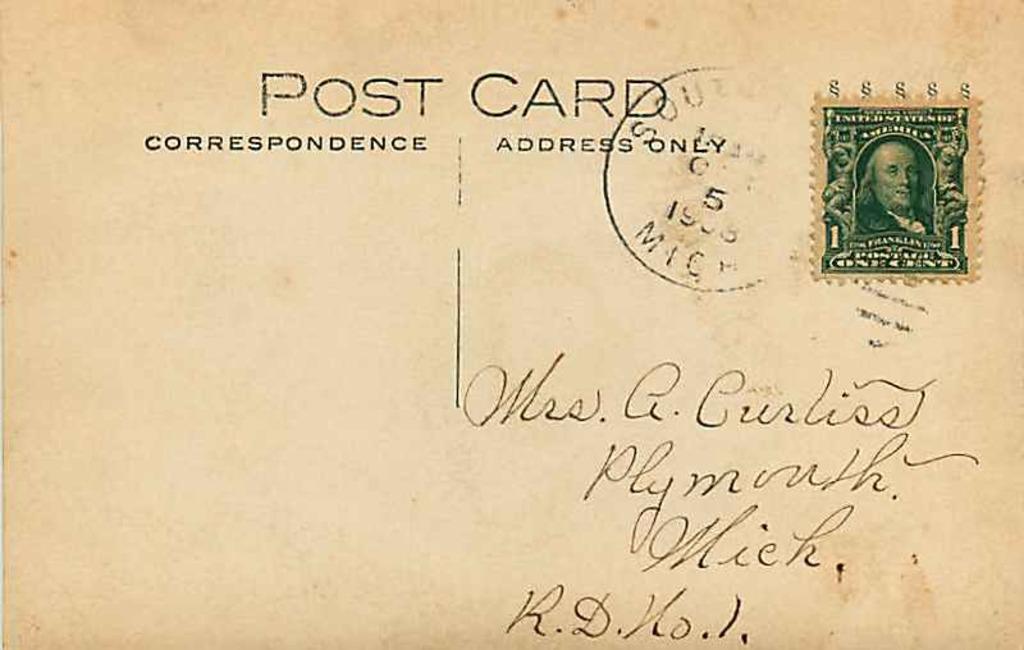What does it say at the top of this card?
Make the answer very short. Post card. Is this to a female?
Offer a very short reply. Yes. 